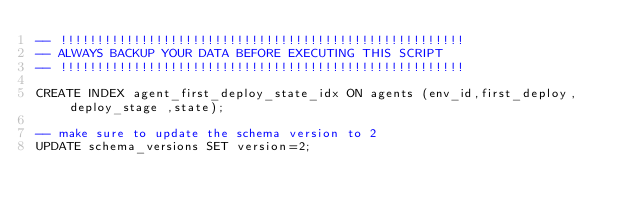<code> <loc_0><loc_0><loc_500><loc_500><_SQL_>-- !!!!!!!!!!!!!!!!!!!!!!!!!!!!!!!!!!!!!!!!!!!!!!!!!!!!!!!
-- ALWAYS BACKUP YOUR DATA BEFORE EXECUTING THIS SCRIPT   
-- !!!!!!!!!!!!!!!!!!!!!!!!!!!!!!!!!!!!!!!!!!!!!!!!!!!!!!!

CREATE INDEX agent_first_deploy_state_idx ON agents (env_id,first_deploy, deploy_stage ,state);

-- make sure to update the schema version to 2
UPDATE schema_versions SET version=2;
</code> 